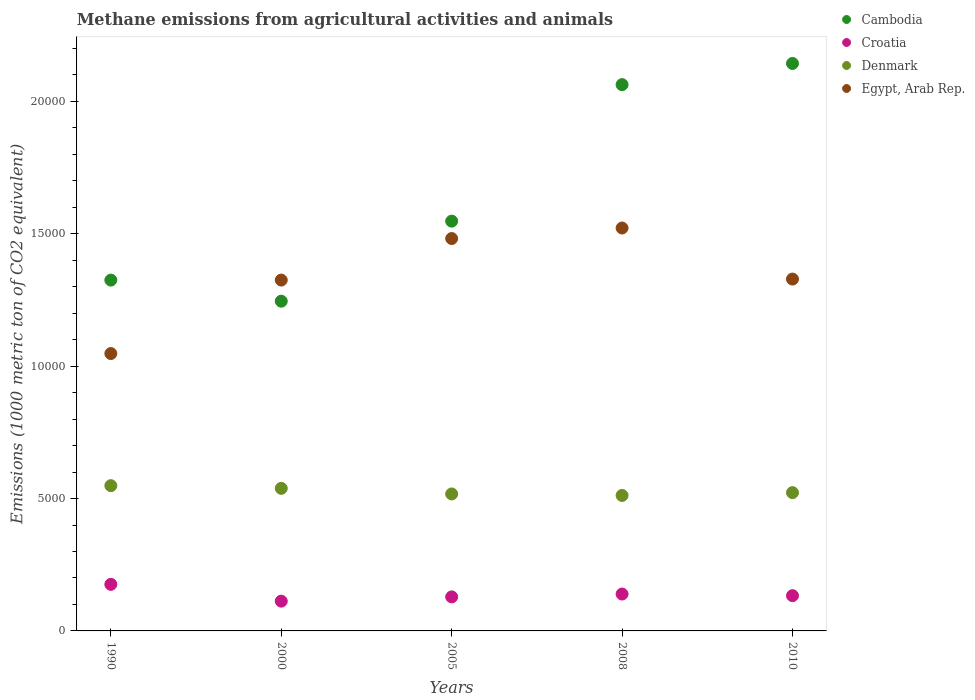Is the number of dotlines equal to the number of legend labels?
Offer a terse response. Yes. What is the amount of methane emitted in Cambodia in 1990?
Your answer should be compact. 1.32e+04. Across all years, what is the maximum amount of methane emitted in Denmark?
Make the answer very short. 5486.2. Across all years, what is the minimum amount of methane emitted in Cambodia?
Your answer should be very brief. 1.25e+04. In which year was the amount of methane emitted in Croatia maximum?
Provide a short and direct response. 1990. In which year was the amount of methane emitted in Denmark minimum?
Your answer should be compact. 2008. What is the total amount of methane emitted in Denmark in the graph?
Your answer should be compact. 2.64e+04. What is the difference between the amount of methane emitted in Denmark in 2005 and that in 2008?
Give a very brief answer. 56.8. What is the difference between the amount of methane emitted in Cambodia in 2000 and the amount of methane emitted in Denmark in 2010?
Provide a succinct answer. 7230.5. What is the average amount of methane emitted in Croatia per year?
Give a very brief answer. 1378.58. In the year 2008, what is the difference between the amount of methane emitted in Denmark and amount of methane emitted in Croatia?
Keep it short and to the point. 3723.9. In how many years, is the amount of methane emitted in Egypt, Arab Rep. greater than 11000 1000 metric ton?
Offer a very short reply. 4. What is the ratio of the amount of methane emitted in Croatia in 2000 to that in 2008?
Offer a terse response. 0.81. Is the amount of methane emitted in Croatia in 2000 less than that in 2008?
Ensure brevity in your answer.  Yes. What is the difference between the highest and the second highest amount of methane emitted in Egypt, Arab Rep.?
Your answer should be very brief. 397.3. What is the difference between the highest and the lowest amount of methane emitted in Egypt, Arab Rep.?
Your answer should be compact. 4741.1. Is it the case that in every year, the sum of the amount of methane emitted in Egypt, Arab Rep. and amount of methane emitted in Croatia  is greater than the sum of amount of methane emitted in Denmark and amount of methane emitted in Cambodia?
Make the answer very short. Yes. Does the amount of methane emitted in Cambodia monotonically increase over the years?
Give a very brief answer. No. Is the amount of methane emitted in Denmark strictly less than the amount of methane emitted in Egypt, Arab Rep. over the years?
Your response must be concise. Yes. What is the difference between two consecutive major ticks on the Y-axis?
Provide a short and direct response. 5000. Where does the legend appear in the graph?
Provide a succinct answer. Top right. What is the title of the graph?
Provide a succinct answer. Methane emissions from agricultural activities and animals. What is the label or title of the X-axis?
Provide a succinct answer. Years. What is the label or title of the Y-axis?
Offer a very short reply. Emissions (1000 metric ton of CO2 equivalent). What is the Emissions (1000 metric ton of CO2 equivalent) in Cambodia in 1990?
Ensure brevity in your answer.  1.32e+04. What is the Emissions (1000 metric ton of CO2 equivalent) of Croatia in 1990?
Ensure brevity in your answer.  1759.1. What is the Emissions (1000 metric ton of CO2 equivalent) in Denmark in 1990?
Keep it short and to the point. 5486.2. What is the Emissions (1000 metric ton of CO2 equivalent) in Egypt, Arab Rep. in 1990?
Keep it short and to the point. 1.05e+04. What is the Emissions (1000 metric ton of CO2 equivalent) of Cambodia in 2000?
Offer a very short reply. 1.25e+04. What is the Emissions (1000 metric ton of CO2 equivalent) in Croatia in 2000?
Make the answer very short. 1124.5. What is the Emissions (1000 metric ton of CO2 equivalent) in Denmark in 2000?
Offer a terse response. 5384.6. What is the Emissions (1000 metric ton of CO2 equivalent) of Egypt, Arab Rep. in 2000?
Give a very brief answer. 1.33e+04. What is the Emissions (1000 metric ton of CO2 equivalent) of Cambodia in 2005?
Keep it short and to the point. 1.55e+04. What is the Emissions (1000 metric ton of CO2 equivalent) of Croatia in 2005?
Provide a short and direct response. 1285.2. What is the Emissions (1000 metric ton of CO2 equivalent) of Denmark in 2005?
Give a very brief answer. 5173.5. What is the Emissions (1000 metric ton of CO2 equivalent) of Egypt, Arab Rep. in 2005?
Provide a succinct answer. 1.48e+04. What is the Emissions (1000 metric ton of CO2 equivalent) of Cambodia in 2008?
Offer a terse response. 2.06e+04. What is the Emissions (1000 metric ton of CO2 equivalent) in Croatia in 2008?
Offer a terse response. 1392.8. What is the Emissions (1000 metric ton of CO2 equivalent) of Denmark in 2008?
Ensure brevity in your answer.  5116.7. What is the Emissions (1000 metric ton of CO2 equivalent) in Egypt, Arab Rep. in 2008?
Give a very brief answer. 1.52e+04. What is the Emissions (1000 metric ton of CO2 equivalent) of Cambodia in 2010?
Your response must be concise. 2.14e+04. What is the Emissions (1000 metric ton of CO2 equivalent) of Croatia in 2010?
Offer a very short reply. 1331.3. What is the Emissions (1000 metric ton of CO2 equivalent) in Denmark in 2010?
Make the answer very short. 5222.8. What is the Emissions (1000 metric ton of CO2 equivalent) in Egypt, Arab Rep. in 2010?
Make the answer very short. 1.33e+04. Across all years, what is the maximum Emissions (1000 metric ton of CO2 equivalent) of Cambodia?
Provide a short and direct response. 2.14e+04. Across all years, what is the maximum Emissions (1000 metric ton of CO2 equivalent) in Croatia?
Ensure brevity in your answer.  1759.1. Across all years, what is the maximum Emissions (1000 metric ton of CO2 equivalent) of Denmark?
Make the answer very short. 5486.2. Across all years, what is the maximum Emissions (1000 metric ton of CO2 equivalent) in Egypt, Arab Rep.?
Your response must be concise. 1.52e+04. Across all years, what is the minimum Emissions (1000 metric ton of CO2 equivalent) of Cambodia?
Make the answer very short. 1.25e+04. Across all years, what is the minimum Emissions (1000 metric ton of CO2 equivalent) in Croatia?
Your response must be concise. 1124.5. Across all years, what is the minimum Emissions (1000 metric ton of CO2 equivalent) of Denmark?
Provide a short and direct response. 5116.7. Across all years, what is the minimum Emissions (1000 metric ton of CO2 equivalent) in Egypt, Arab Rep.?
Make the answer very short. 1.05e+04. What is the total Emissions (1000 metric ton of CO2 equivalent) in Cambodia in the graph?
Keep it short and to the point. 8.32e+04. What is the total Emissions (1000 metric ton of CO2 equivalent) of Croatia in the graph?
Your response must be concise. 6892.9. What is the total Emissions (1000 metric ton of CO2 equivalent) of Denmark in the graph?
Keep it short and to the point. 2.64e+04. What is the total Emissions (1000 metric ton of CO2 equivalent) of Egypt, Arab Rep. in the graph?
Offer a very short reply. 6.71e+04. What is the difference between the Emissions (1000 metric ton of CO2 equivalent) in Cambodia in 1990 and that in 2000?
Ensure brevity in your answer.  796.5. What is the difference between the Emissions (1000 metric ton of CO2 equivalent) of Croatia in 1990 and that in 2000?
Offer a terse response. 634.6. What is the difference between the Emissions (1000 metric ton of CO2 equivalent) in Denmark in 1990 and that in 2000?
Your response must be concise. 101.6. What is the difference between the Emissions (1000 metric ton of CO2 equivalent) in Egypt, Arab Rep. in 1990 and that in 2000?
Provide a short and direct response. -2774.9. What is the difference between the Emissions (1000 metric ton of CO2 equivalent) of Cambodia in 1990 and that in 2005?
Your response must be concise. -2227.1. What is the difference between the Emissions (1000 metric ton of CO2 equivalent) in Croatia in 1990 and that in 2005?
Provide a short and direct response. 473.9. What is the difference between the Emissions (1000 metric ton of CO2 equivalent) of Denmark in 1990 and that in 2005?
Give a very brief answer. 312.7. What is the difference between the Emissions (1000 metric ton of CO2 equivalent) of Egypt, Arab Rep. in 1990 and that in 2005?
Provide a short and direct response. -4343.8. What is the difference between the Emissions (1000 metric ton of CO2 equivalent) of Cambodia in 1990 and that in 2008?
Make the answer very short. -7382.4. What is the difference between the Emissions (1000 metric ton of CO2 equivalent) in Croatia in 1990 and that in 2008?
Ensure brevity in your answer.  366.3. What is the difference between the Emissions (1000 metric ton of CO2 equivalent) of Denmark in 1990 and that in 2008?
Offer a very short reply. 369.5. What is the difference between the Emissions (1000 metric ton of CO2 equivalent) of Egypt, Arab Rep. in 1990 and that in 2008?
Offer a terse response. -4741.1. What is the difference between the Emissions (1000 metric ton of CO2 equivalent) of Cambodia in 1990 and that in 2010?
Offer a terse response. -8182.5. What is the difference between the Emissions (1000 metric ton of CO2 equivalent) of Croatia in 1990 and that in 2010?
Offer a very short reply. 427.8. What is the difference between the Emissions (1000 metric ton of CO2 equivalent) in Denmark in 1990 and that in 2010?
Ensure brevity in your answer.  263.4. What is the difference between the Emissions (1000 metric ton of CO2 equivalent) in Egypt, Arab Rep. in 1990 and that in 2010?
Ensure brevity in your answer.  -2813. What is the difference between the Emissions (1000 metric ton of CO2 equivalent) in Cambodia in 2000 and that in 2005?
Provide a short and direct response. -3023.6. What is the difference between the Emissions (1000 metric ton of CO2 equivalent) in Croatia in 2000 and that in 2005?
Make the answer very short. -160.7. What is the difference between the Emissions (1000 metric ton of CO2 equivalent) of Denmark in 2000 and that in 2005?
Your response must be concise. 211.1. What is the difference between the Emissions (1000 metric ton of CO2 equivalent) in Egypt, Arab Rep. in 2000 and that in 2005?
Your response must be concise. -1568.9. What is the difference between the Emissions (1000 metric ton of CO2 equivalent) in Cambodia in 2000 and that in 2008?
Make the answer very short. -8178.9. What is the difference between the Emissions (1000 metric ton of CO2 equivalent) in Croatia in 2000 and that in 2008?
Your response must be concise. -268.3. What is the difference between the Emissions (1000 metric ton of CO2 equivalent) in Denmark in 2000 and that in 2008?
Your response must be concise. 267.9. What is the difference between the Emissions (1000 metric ton of CO2 equivalent) of Egypt, Arab Rep. in 2000 and that in 2008?
Your answer should be compact. -1966.2. What is the difference between the Emissions (1000 metric ton of CO2 equivalent) of Cambodia in 2000 and that in 2010?
Provide a succinct answer. -8979. What is the difference between the Emissions (1000 metric ton of CO2 equivalent) of Croatia in 2000 and that in 2010?
Your answer should be very brief. -206.8. What is the difference between the Emissions (1000 metric ton of CO2 equivalent) of Denmark in 2000 and that in 2010?
Ensure brevity in your answer.  161.8. What is the difference between the Emissions (1000 metric ton of CO2 equivalent) of Egypt, Arab Rep. in 2000 and that in 2010?
Your answer should be very brief. -38.1. What is the difference between the Emissions (1000 metric ton of CO2 equivalent) in Cambodia in 2005 and that in 2008?
Give a very brief answer. -5155.3. What is the difference between the Emissions (1000 metric ton of CO2 equivalent) of Croatia in 2005 and that in 2008?
Give a very brief answer. -107.6. What is the difference between the Emissions (1000 metric ton of CO2 equivalent) in Denmark in 2005 and that in 2008?
Keep it short and to the point. 56.8. What is the difference between the Emissions (1000 metric ton of CO2 equivalent) of Egypt, Arab Rep. in 2005 and that in 2008?
Give a very brief answer. -397.3. What is the difference between the Emissions (1000 metric ton of CO2 equivalent) in Cambodia in 2005 and that in 2010?
Ensure brevity in your answer.  -5955.4. What is the difference between the Emissions (1000 metric ton of CO2 equivalent) in Croatia in 2005 and that in 2010?
Offer a very short reply. -46.1. What is the difference between the Emissions (1000 metric ton of CO2 equivalent) of Denmark in 2005 and that in 2010?
Offer a very short reply. -49.3. What is the difference between the Emissions (1000 metric ton of CO2 equivalent) of Egypt, Arab Rep. in 2005 and that in 2010?
Ensure brevity in your answer.  1530.8. What is the difference between the Emissions (1000 metric ton of CO2 equivalent) of Cambodia in 2008 and that in 2010?
Your answer should be very brief. -800.1. What is the difference between the Emissions (1000 metric ton of CO2 equivalent) of Croatia in 2008 and that in 2010?
Give a very brief answer. 61.5. What is the difference between the Emissions (1000 metric ton of CO2 equivalent) in Denmark in 2008 and that in 2010?
Offer a terse response. -106.1. What is the difference between the Emissions (1000 metric ton of CO2 equivalent) of Egypt, Arab Rep. in 2008 and that in 2010?
Your answer should be compact. 1928.1. What is the difference between the Emissions (1000 metric ton of CO2 equivalent) of Cambodia in 1990 and the Emissions (1000 metric ton of CO2 equivalent) of Croatia in 2000?
Give a very brief answer. 1.21e+04. What is the difference between the Emissions (1000 metric ton of CO2 equivalent) of Cambodia in 1990 and the Emissions (1000 metric ton of CO2 equivalent) of Denmark in 2000?
Provide a short and direct response. 7865.2. What is the difference between the Emissions (1000 metric ton of CO2 equivalent) in Croatia in 1990 and the Emissions (1000 metric ton of CO2 equivalent) in Denmark in 2000?
Make the answer very short. -3625.5. What is the difference between the Emissions (1000 metric ton of CO2 equivalent) of Croatia in 1990 and the Emissions (1000 metric ton of CO2 equivalent) of Egypt, Arab Rep. in 2000?
Provide a short and direct response. -1.15e+04. What is the difference between the Emissions (1000 metric ton of CO2 equivalent) in Denmark in 1990 and the Emissions (1000 metric ton of CO2 equivalent) in Egypt, Arab Rep. in 2000?
Make the answer very short. -7764.8. What is the difference between the Emissions (1000 metric ton of CO2 equivalent) in Cambodia in 1990 and the Emissions (1000 metric ton of CO2 equivalent) in Croatia in 2005?
Make the answer very short. 1.20e+04. What is the difference between the Emissions (1000 metric ton of CO2 equivalent) of Cambodia in 1990 and the Emissions (1000 metric ton of CO2 equivalent) of Denmark in 2005?
Ensure brevity in your answer.  8076.3. What is the difference between the Emissions (1000 metric ton of CO2 equivalent) in Cambodia in 1990 and the Emissions (1000 metric ton of CO2 equivalent) in Egypt, Arab Rep. in 2005?
Give a very brief answer. -1570.1. What is the difference between the Emissions (1000 metric ton of CO2 equivalent) of Croatia in 1990 and the Emissions (1000 metric ton of CO2 equivalent) of Denmark in 2005?
Keep it short and to the point. -3414.4. What is the difference between the Emissions (1000 metric ton of CO2 equivalent) of Croatia in 1990 and the Emissions (1000 metric ton of CO2 equivalent) of Egypt, Arab Rep. in 2005?
Provide a short and direct response. -1.31e+04. What is the difference between the Emissions (1000 metric ton of CO2 equivalent) in Denmark in 1990 and the Emissions (1000 metric ton of CO2 equivalent) in Egypt, Arab Rep. in 2005?
Offer a terse response. -9333.7. What is the difference between the Emissions (1000 metric ton of CO2 equivalent) in Cambodia in 1990 and the Emissions (1000 metric ton of CO2 equivalent) in Croatia in 2008?
Keep it short and to the point. 1.19e+04. What is the difference between the Emissions (1000 metric ton of CO2 equivalent) in Cambodia in 1990 and the Emissions (1000 metric ton of CO2 equivalent) in Denmark in 2008?
Give a very brief answer. 8133.1. What is the difference between the Emissions (1000 metric ton of CO2 equivalent) in Cambodia in 1990 and the Emissions (1000 metric ton of CO2 equivalent) in Egypt, Arab Rep. in 2008?
Offer a terse response. -1967.4. What is the difference between the Emissions (1000 metric ton of CO2 equivalent) in Croatia in 1990 and the Emissions (1000 metric ton of CO2 equivalent) in Denmark in 2008?
Give a very brief answer. -3357.6. What is the difference between the Emissions (1000 metric ton of CO2 equivalent) in Croatia in 1990 and the Emissions (1000 metric ton of CO2 equivalent) in Egypt, Arab Rep. in 2008?
Provide a succinct answer. -1.35e+04. What is the difference between the Emissions (1000 metric ton of CO2 equivalent) in Denmark in 1990 and the Emissions (1000 metric ton of CO2 equivalent) in Egypt, Arab Rep. in 2008?
Your answer should be very brief. -9731. What is the difference between the Emissions (1000 metric ton of CO2 equivalent) of Cambodia in 1990 and the Emissions (1000 metric ton of CO2 equivalent) of Croatia in 2010?
Your response must be concise. 1.19e+04. What is the difference between the Emissions (1000 metric ton of CO2 equivalent) of Cambodia in 1990 and the Emissions (1000 metric ton of CO2 equivalent) of Denmark in 2010?
Offer a terse response. 8027. What is the difference between the Emissions (1000 metric ton of CO2 equivalent) of Cambodia in 1990 and the Emissions (1000 metric ton of CO2 equivalent) of Egypt, Arab Rep. in 2010?
Provide a short and direct response. -39.3. What is the difference between the Emissions (1000 metric ton of CO2 equivalent) in Croatia in 1990 and the Emissions (1000 metric ton of CO2 equivalent) in Denmark in 2010?
Provide a short and direct response. -3463.7. What is the difference between the Emissions (1000 metric ton of CO2 equivalent) in Croatia in 1990 and the Emissions (1000 metric ton of CO2 equivalent) in Egypt, Arab Rep. in 2010?
Keep it short and to the point. -1.15e+04. What is the difference between the Emissions (1000 metric ton of CO2 equivalent) in Denmark in 1990 and the Emissions (1000 metric ton of CO2 equivalent) in Egypt, Arab Rep. in 2010?
Give a very brief answer. -7802.9. What is the difference between the Emissions (1000 metric ton of CO2 equivalent) of Cambodia in 2000 and the Emissions (1000 metric ton of CO2 equivalent) of Croatia in 2005?
Give a very brief answer. 1.12e+04. What is the difference between the Emissions (1000 metric ton of CO2 equivalent) of Cambodia in 2000 and the Emissions (1000 metric ton of CO2 equivalent) of Denmark in 2005?
Make the answer very short. 7279.8. What is the difference between the Emissions (1000 metric ton of CO2 equivalent) in Cambodia in 2000 and the Emissions (1000 metric ton of CO2 equivalent) in Egypt, Arab Rep. in 2005?
Give a very brief answer. -2366.6. What is the difference between the Emissions (1000 metric ton of CO2 equivalent) in Croatia in 2000 and the Emissions (1000 metric ton of CO2 equivalent) in Denmark in 2005?
Give a very brief answer. -4049. What is the difference between the Emissions (1000 metric ton of CO2 equivalent) in Croatia in 2000 and the Emissions (1000 metric ton of CO2 equivalent) in Egypt, Arab Rep. in 2005?
Keep it short and to the point. -1.37e+04. What is the difference between the Emissions (1000 metric ton of CO2 equivalent) of Denmark in 2000 and the Emissions (1000 metric ton of CO2 equivalent) of Egypt, Arab Rep. in 2005?
Keep it short and to the point. -9435.3. What is the difference between the Emissions (1000 metric ton of CO2 equivalent) of Cambodia in 2000 and the Emissions (1000 metric ton of CO2 equivalent) of Croatia in 2008?
Give a very brief answer. 1.11e+04. What is the difference between the Emissions (1000 metric ton of CO2 equivalent) of Cambodia in 2000 and the Emissions (1000 metric ton of CO2 equivalent) of Denmark in 2008?
Your response must be concise. 7336.6. What is the difference between the Emissions (1000 metric ton of CO2 equivalent) in Cambodia in 2000 and the Emissions (1000 metric ton of CO2 equivalent) in Egypt, Arab Rep. in 2008?
Offer a very short reply. -2763.9. What is the difference between the Emissions (1000 metric ton of CO2 equivalent) of Croatia in 2000 and the Emissions (1000 metric ton of CO2 equivalent) of Denmark in 2008?
Your response must be concise. -3992.2. What is the difference between the Emissions (1000 metric ton of CO2 equivalent) in Croatia in 2000 and the Emissions (1000 metric ton of CO2 equivalent) in Egypt, Arab Rep. in 2008?
Your response must be concise. -1.41e+04. What is the difference between the Emissions (1000 metric ton of CO2 equivalent) of Denmark in 2000 and the Emissions (1000 metric ton of CO2 equivalent) of Egypt, Arab Rep. in 2008?
Give a very brief answer. -9832.6. What is the difference between the Emissions (1000 metric ton of CO2 equivalent) in Cambodia in 2000 and the Emissions (1000 metric ton of CO2 equivalent) in Croatia in 2010?
Your answer should be very brief. 1.11e+04. What is the difference between the Emissions (1000 metric ton of CO2 equivalent) in Cambodia in 2000 and the Emissions (1000 metric ton of CO2 equivalent) in Denmark in 2010?
Provide a succinct answer. 7230.5. What is the difference between the Emissions (1000 metric ton of CO2 equivalent) of Cambodia in 2000 and the Emissions (1000 metric ton of CO2 equivalent) of Egypt, Arab Rep. in 2010?
Your answer should be compact. -835.8. What is the difference between the Emissions (1000 metric ton of CO2 equivalent) in Croatia in 2000 and the Emissions (1000 metric ton of CO2 equivalent) in Denmark in 2010?
Offer a very short reply. -4098.3. What is the difference between the Emissions (1000 metric ton of CO2 equivalent) of Croatia in 2000 and the Emissions (1000 metric ton of CO2 equivalent) of Egypt, Arab Rep. in 2010?
Offer a terse response. -1.22e+04. What is the difference between the Emissions (1000 metric ton of CO2 equivalent) of Denmark in 2000 and the Emissions (1000 metric ton of CO2 equivalent) of Egypt, Arab Rep. in 2010?
Ensure brevity in your answer.  -7904.5. What is the difference between the Emissions (1000 metric ton of CO2 equivalent) in Cambodia in 2005 and the Emissions (1000 metric ton of CO2 equivalent) in Croatia in 2008?
Your response must be concise. 1.41e+04. What is the difference between the Emissions (1000 metric ton of CO2 equivalent) of Cambodia in 2005 and the Emissions (1000 metric ton of CO2 equivalent) of Denmark in 2008?
Your answer should be very brief. 1.04e+04. What is the difference between the Emissions (1000 metric ton of CO2 equivalent) in Cambodia in 2005 and the Emissions (1000 metric ton of CO2 equivalent) in Egypt, Arab Rep. in 2008?
Provide a short and direct response. 259.7. What is the difference between the Emissions (1000 metric ton of CO2 equivalent) of Croatia in 2005 and the Emissions (1000 metric ton of CO2 equivalent) of Denmark in 2008?
Offer a terse response. -3831.5. What is the difference between the Emissions (1000 metric ton of CO2 equivalent) of Croatia in 2005 and the Emissions (1000 metric ton of CO2 equivalent) of Egypt, Arab Rep. in 2008?
Provide a succinct answer. -1.39e+04. What is the difference between the Emissions (1000 metric ton of CO2 equivalent) of Denmark in 2005 and the Emissions (1000 metric ton of CO2 equivalent) of Egypt, Arab Rep. in 2008?
Make the answer very short. -1.00e+04. What is the difference between the Emissions (1000 metric ton of CO2 equivalent) of Cambodia in 2005 and the Emissions (1000 metric ton of CO2 equivalent) of Croatia in 2010?
Offer a terse response. 1.41e+04. What is the difference between the Emissions (1000 metric ton of CO2 equivalent) of Cambodia in 2005 and the Emissions (1000 metric ton of CO2 equivalent) of Denmark in 2010?
Provide a short and direct response. 1.03e+04. What is the difference between the Emissions (1000 metric ton of CO2 equivalent) of Cambodia in 2005 and the Emissions (1000 metric ton of CO2 equivalent) of Egypt, Arab Rep. in 2010?
Make the answer very short. 2187.8. What is the difference between the Emissions (1000 metric ton of CO2 equivalent) in Croatia in 2005 and the Emissions (1000 metric ton of CO2 equivalent) in Denmark in 2010?
Make the answer very short. -3937.6. What is the difference between the Emissions (1000 metric ton of CO2 equivalent) of Croatia in 2005 and the Emissions (1000 metric ton of CO2 equivalent) of Egypt, Arab Rep. in 2010?
Ensure brevity in your answer.  -1.20e+04. What is the difference between the Emissions (1000 metric ton of CO2 equivalent) in Denmark in 2005 and the Emissions (1000 metric ton of CO2 equivalent) in Egypt, Arab Rep. in 2010?
Provide a succinct answer. -8115.6. What is the difference between the Emissions (1000 metric ton of CO2 equivalent) in Cambodia in 2008 and the Emissions (1000 metric ton of CO2 equivalent) in Croatia in 2010?
Your response must be concise. 1.93e+04. What is the difference between the Emissions (1000 metric ton of CO2 equivalent) of Cambodia in 2008 and the Emissions (1000 metric ton of CO2 equivalent) of Denmark in 2010?
Provide a short and direct response. 1.54e+04. What is the difference between the Emissions (1000 metric ton of CO2 equivalent) of Cambodia in 2008 and the Emissions (1000 metric ton of CO2 equivalent) of Egypt, Arab Rep. in 2010?
Keep it short and to the point. 7343.1. What is the difference between the Emissions (1000 metric ton of CO2 equivalent) in Croatia in 2008 and the Emissions (1000 metric ton of CO2 equivalent) in Denmark in 2010?
Your response must be concise. -3830. What is the difference between the Emissions (1000 metric ton of CO2 equivalent) in Croatia in 2008 and the Emissions (1000 metric ton of CO2 equivalent) in Egypt, Arab Rep. in 2010?
Your answer should be very brief. -1.19e+04. What is the difference between the Emissions (1000 metric ton of CO2 equivalent) of Denmark in 2008 and the Emissions (1000 metric ton of CO2 equivalent) of Egypt, Arab Rep. in 2010?
Offer a terse response. -8172.4. What is the average Emissions (1000 metric ton of CO2 equivalent) in Cambodia per year?
Your response must be concise. 1.66e+04. What is the average Emissions (1000 metric ton of CO2 equivalent) of Croatia per year?
Provide a short and direct response. 1378.58. What is the average Emissions (1000 metric ton of CO2 equivalent) of Denmark per year?
Give a very brief answer. 5276.76. What is the average Emissions (1000 metric ton of CO2 equivalent) in Egypt, Arab Rep. per year?
Offer a terse response. 1.34e+04. In the year 1990, what is the difference between the Emissions (1000 metric ton of CO2 equivalent) of Cambodia and Emissions (1000 metric ton of CO2 equivalent) of Croatia?
Ensure brevity in your answer.  1.15e+04. In the year 1990, what is the difference between the Emissions (1000 metric ton of CO2 equivalent) of Cambodia and Emissions (1000 metric ton of CO2 equivalent) of Denmark?
Offer a terse response. 7763.6. In the year 1990, what is the difference between the Emissions (1000 metric ton of CO2 equivalent) in Cambodia and Emissions (1000 metric ton of CO2 equivalent) in Egypt, Arab Rep.?
Your response must be concise. 2773.7. In the year 1990, what is the difference between the Emissions (1000 metric ton of CO2 equivalent) in Croatia and Emissions (1000 metric ton of CO2 equivalent) in Denmark?
Your answer should be compact. -3727.1. In the year 1990, what is the difference between the Emissions (1000 metric ton of CO2 equivalent) in Croatia and Emissions (1000 metric ton of CO2 equivalent) in Egypt, Arab Rep.?
Ensure brevity in your answer.  -8717. In the year 1990, what is the difference between the Emissions (1000 metric ton of CO2 equivalent) in Denmark and Emissions (1000 metric ton of CO2 equivalent) in Egypt, Arab Rep.?
Offer a very short reply. -4989.9. In the year 2000, what is the difference between the Emissions (1000 metric ton of CO2 equivalent) in Cambodia and Emissions (1000 metric ton of CO2 equivalent) in Croatia?
Give a very brief answer. 1.13e+04. In the year 2000, what is the difference between the Emissions (1000 metric ton of CO2 equivalent) of Cambodia and Emissions (1000 metric ton of CO2 equivalent) of Denmark?
Ensure brevity in your answer.  7068.7. In the year 2000, what is the difference between the Emissions (1000 metric ton of CO2 equivalent) in Cambodia and Emissions (1000 metric ton of CO2 equivalent) in Egypt, Arab Rep.?
Provide a short and direct response. -797.7. In the year 2000, what is the difference between the Emissions (1000 metric ton of CO2 equivalent) in Croatia and Emissions (1000 metric ton of CO2 equivalent) in Denmark?
Offer a very short reply. -4260.1. In the year 2000, what is the difference between the Emissions (1000 metric ton of CO2 equivalent) of Croatia and Emissions (1000 metric ton of CO2 equivalent) of Egypt, Arab Rep.?
Your answer should be compact. -1.21e+04. In the year 2000, what is the difference between the Emissions (1000 metric ton of CO2 equivalent) of Denmark and Emissions (1000 metric ton of CO2 equivalent) of Egypt, Arab Rep.?
Offer a terse response. -7866.4. In the year 2005, what is the difference between the Emissions (1000 metric ton of CO2 equivalent) of Cambodia and Emissions (1000 metric ton of CO2 equivalent) of Croatia?
Make the answer very short. 1.42e+04. In the year 2005, what is the difference between the Emissions (1000 metric ton of CO2 equivalent) in Cambodia and Emissions (1000 metric ton of CO2 equivalent) in Denmark?
Make the answer very short. 1.03e+04. In the year 2005, what is the difference between the Emissions (1000 metric ton of CO2 equivalent) in Cambodia and Emissions (1000 metric ton of CO2 equivalent) in Egypt, Arab Rep.?
Ensure brevity in your answer.  657. In the year 2005, what is the difference between the Emissions (1000 metric ton of CO2 equivalent) in Croatia and Emissions (1000 metric ton of CO2 equivalent) in Denmark?
Offer a very short reply. -3888.3. In the year 2005, what is the difference between the Emissions (1000 metric ton of CO2 equivalent) of Croatia and Emissions (1000 metric ton of CO2 equivalent) of Egypt, Arab Rep.?
Give a very brief answer. -1.35e+04. In the year 2005, what is the difference between the Emissions (1000 metric ton of CO2 equivalent) of Denmark and Emissions (1000 metric ton of CO2 equivalent) of Egypt, Arab Rep.?
Provide a short and direct response. -9646.4. In the year 2008, what is the difference between the Emissions (1000 metric ton of CO2 equivalent) of Cambodia and Emissions (1000 metric ton of CO2 equivalent) of Croatia?
Make the answer very short. 1.92e+04. In the year 2008, what is the difference between the Emissions (1000 metric ton of CO2 equivalent) of Cambodia and Emissions (1000 metric ton of CO2 equivalent) of Denmark?
Your answer should be very brief. 1.55e+04. In the year 2008, what is the difference between the Emissions (1000 metric ton of CO2 equivalent) in Cambodia and Emissions (1000 metric ton of CO2 equivalent) in Egypt, Arab Rep.?
Give a very brief answer. 5415. In the year 2008, what is the difference between the Emissions (1000 metric ton of CO2 equivalent) in Croatia and Emissions (1000 metric ton of CO2 equivalent) in Denmark?
Make the answer very short. -3723.9. In the year 2008, what is the difference between the Emissions (1000 metric ton of CO2 equivalent) in Croatia and Emissions (1000 metric ton of CO2 equivalent) in Egypt, Arab Rep.?
Offer a terse response. -1.38e+04. In the year 2008, what is the difference between the Emissions (1000 metric ton of CO2 equivalent) of Denmark and Emissions (1000 metric ton of CO2 equivalent) of Egypt, Arab Rep.?
Give a very brief answer. -1.01e+04. In the year 2010, what is the difference between the Emissions (1000 metric ton of CO2 equivalent) of Cambodia and Emissions (1000 metric ton of CO2 equivalent) of Croatia?
Provide a short and direct response. 2.01e+04. In the year 2010, what is the difference between the Emissions (1000 metric ton of CO2 equivalent) in Cambodia and Emissions (1000 metric ton of CO2 equivalent) in Denmark?
Provide a succinct answer. 1.62e+04. In the year 2010, what is the difference between the Emissions (1000 metric ton of CO2 equivalent) in Cambodia and Emissions (1000 metric ton of CO2 equivalent) in Egypt, Arab Rep.?
Your answer should be compact. 8143.2. In the year 2010, what is the difference between the Emissions (1000 metric ton of CO2 equivalent) of Croatia and Emissions (1000 metric ton of CO2 equivalent) of Denmark?
Make the answer very short. -3891.5. In the year 2010, what is the difference between the Emissions (1000 metric ton of CO2 equivalent) in Croatia and Emissions (1000 metric ton of CO2 equivalent) in Egypt, Arab Rep.?
Keep it short and to the point. -1.20e+04. In the year 2010, what is the difference between the Emissions (1000 metric ton of CO2 equivalent) of Denmark and Emissions (1000 metric ton of CO2 equivalent) of Egypt, Arab Rep.?
Make the answer very short. -8066.3. What is the ratio of the Emissions (1000 metric ton of CO2 equivalent) in Cambodia in 1990 to that in 2000?
Your answer should be compact. 1.06. What is the ratio of the Emissions (1000 metric ton of CO2 equivalent) of Croatia in 1990 to that in 2000?
Keep it short and to the point. 1.56. What is the ratio of the Emissions (1000 metric ton of CO2 equivalent) of Denmark in 1990 to that in 2000?
Ensure brevity in your answer.  1.02. What is the ratio of the Emissions (1000 metric ton of CO2 equivalent) of Egypt, Arab Rep. in 1990 to that in 2000?
Offer a terse response. 0.79. What is the ratio of the Emissions (1000 metric ton of CO2 equivalent) in Cambodia in 1990 to that in 2005?
Your response must be concise. 0.86. What is the ratio of the Emissions (1000 metric ton of CO2 equivalent) in Croatia in 1990 to that in 2005?
Keep it short and to the point. 1.37. What is the ratio of the Emissions (1000 metric ton of CO2 equivalent) of Denmark in 1990 to that in 2005?
Keep it short and to the point. 1.06. What is the ratio of the Emissions (1000 metric ton of CO2 equivalent) in Egypt, Arab Rep. in 1990 to that in 2005?
Provide a short and direct response. 0.71. What is the ratio of the Emissions (1000 metric ton of CO2 equivalent) in Cambodia in 1990 to that in 2008?
Give a very brief answer. 0.64. What is the ratio of the Emissions (1000 metric ton of CO2 equivalent) of Croatia in 1990 to that in 2008?
Offer a terse response. 1.26. What is the ratio of the Emissions (1000 metric ton of CO2 equivalent) in Denmark in 1990 to that in 2008?
Offer a very short reply. 1.07. What is the ratio of the Emissions (1000 metric ton of CO2 equivalent) of Egypt, Arab Rep. in 1990 to that in 2008?
Ensure brevity in your answer.  0.69. What is the ratio of the Emissions (1000 metric ton of CO2 equivalent) of Cambodia in 1990 to that in 2010?
Give a very brief answer. 0.62. What is the ratio of the Emissions (1000 metric ton of CO2 equivalent) of Croatia in 1990 to that in 2010?
Provide a succinct answer. 1.32. What is the ratio of the Emissions (1000 metric ton of CO2 equivalent) in Denmark in 1990 to that in 2010?
Give a very brief answer. 1.05. What is the ratio of the Emissions (1000 metric ton of CO2 equivalent) of Egypt, Arab Rep. in 1990 to that in 2010?
Provide a succinct answer. 0.79. What is the ratio of the Emissions (1000 metric ton of CO2 equivalent) in Cambodia in 2000 to that in 2005?
Offer a terse response. 0.8. What is the ratio of the Emissions (1000 metric ton of CO2 equivalent) in Denmark in 2000 to that in 2005?
Keep it short and to the point. 1.04. What is the ratio of the Emissions (1000 metric ton of CO2 equivalent) of Egypt, Arab Rep. in 2000 to that in 2005?
Give a very brief answer. 0.89. What is the ratio of the Emissions (1000 metric ton of CO2 equivalent) in Cambodia in 2000 to that in 2008?
Your answer should be compact. 0.6. What is the ratio of the Emissions (1000 metric ton of CO2 equivalent) in Croatia in 2000 to that in 2008?
Offer a very short reply. 0.81. What is the ratio of the Emissions (1000 metric ton of CO2 equivalent) of Denmark in 2000 to that in 2008?
Offer a very short reply. 1.05. What is the ratio of the Emissions (1000 metric ton of CO2 equivalent) in Egypt, Arab Rep. in 2000 to that in 2008?
Ensure brevity in your answer.  0.87. What is the ratio of the Emissions (1000 metric ton of CO2 equivalent) in Cambodia in 2000 to that in 2010?
Offer a terse response. 0.58. What is the ratio of the Emissions (1000 metric ton of CO2 equivalent) of Croatia in 2000 to that in 2010?
Make the answer very short. 0.84. What is the ratio of the Emissions (1000 metric ton of CO2 equivalent) in Denmark in 2000 to that in 2010?
Offer a very short reply. 1.03. What is the ratio of the Emissions (1000 metric ton of CO2 equivalent) in Cambodia in 2005 to that in 2008?
Provide a succinct answer. 0.75. What is the ratio of the Emissions (1000 metric ton of CO2 equivalent) in Croatia in 2005 to that in 2008?
Keep it short and to the point. 0.92. What is the ratio of the Emissions (1000 metric ton of CO2 equivalent) of Denmark in 2005 to that in 2008?
Offer a terse response. 1.01. What is the ratio of the Emissions (1000 metric ton of CO2 equivalent) in Egypt, Arab Rep. in 2005 to that in 2008?
Offer a very short reply. 0.97. What is the ratio of the Emissions (1000 metric ton of CO2 equivalent) in Cambodia in 2005 to that in 2010?
Your answer should be compact. 0.72. What is the ratio of the Emissions (1000 metric ton of CO2 equivalent) of Croatia in 2005 to that in 2010?
Provide a short and direct response. 0.97. What is the ratio of the Emissions (1000 metric ton of CO2 equivalent) of Denmark in 2005 to that in 2010?
Ensure brevity in your answer.  0.99. What is the ratio of the Emissions (1000 metric ton of CO2 equivalent) of Egypt, Arab Rep. in 2005 to that in 2010?
Offer a terse response. 1.12. What is the ratio of the Emissions (1000 metric ton of CO2 equivalent) in Cambodia in 2008 to that in 2010?
Your answer should be compact. 0.96. What is the ratio of the Emissions (1000 metric ton of CO2 equivalent) in Croatia in 2008 to that in 2010?
Ensure brevity in your answer.  1.05. What is the ratio of the Emissions (1000 metric ton of CO2 equivalent) in Denmark in 2008 to that in 2010?
Provide a succinct answer. 0.98. What is the ratio of the Emissions (1000 metric ton of CO2 equivalent) of Egypt, Arab Rep. in 2008 to that in 2010?
Provide a short and direct response. 1.15. What is the difference between the highest and the second highest Emissions (1000 metric ton of CO2 equivalent) in Cambodia?
Give a very brief answer. 800.1. What is the difference between the highest and the second highest Emissions (1000 metric ton of CO2 equivalent) of Croatia?
Offer a very short reply. 366.3. What is the difference between the highest and the second highest Emissions (1000 metric ton of CO2 equivalent) in Denmark?
Keep it short and to the point. 101.6. What is the difference between the highest and the second highest Emissions (1000 metric ton of CO2 equivalent) in Egypt, Arab Rep.?
Your response must be concise. 397.3. What is the difference between the highest and the lowest Emissions (1000 metric ton of CO2 equivalent) of Cambodia?
Offer a terse response. 8979. What is the difference between the highest and the lowest Emissions (1000 metric ton of CO2 equivalent) in Croatia?
Keep it short and to the point. 634.6. What is the difference between the highest and the lowest Emissions (1000 metric ton of CO2 equivalent) of Denmark?
Provide a short and direct response. 369.5. What is the difference between the highest and the lowest Emissions (1000 metric ton of CO2 equivalent) in Egypt, Arab Rep.?
Offer a very short reply. 4741.1. 